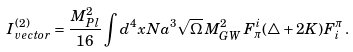<formula> <loc_0><loc_0><loc_500><loc_500>I ^ { ( 2 ) } _ { v e c t o r } = \frac { M _ { P l } ^ { 2 } } { 1 6 } \int d ^ { 4 } x N a ^ { 3 } \sqrt { \Omega } \, M ^ { 2 } _ { G W } \, F _ { \pi } ^ { i } ( \triangle + 2 K ) F ^ { \pi } _ { i } \, .</formula> 